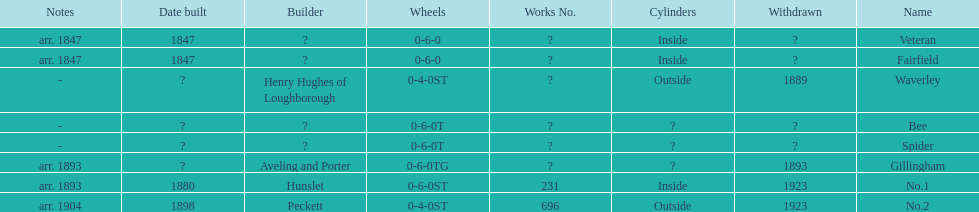What is the total number of names on the chart? 8. 